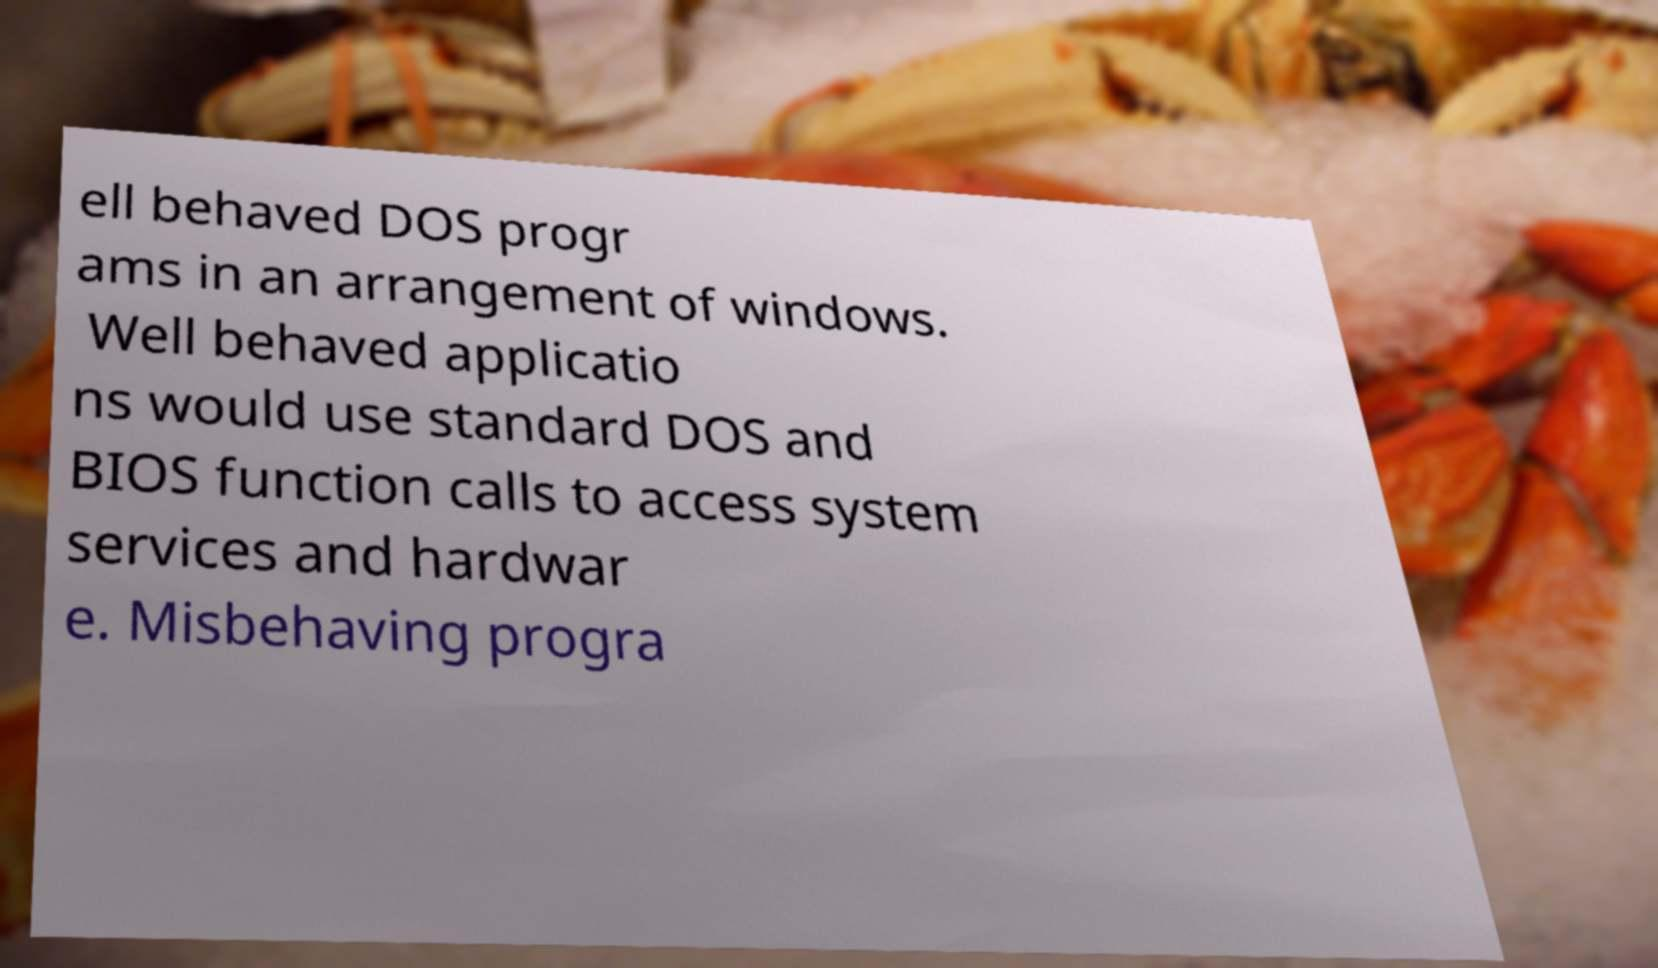I need the written content from this picture converted into text. Can you do that? ell behaved DOS progr ams in an arrangement of windows. Well behaved applicatio ns would use standard DOS and BIOS function calls to access system services and hardwar e. Misbehaving progra 